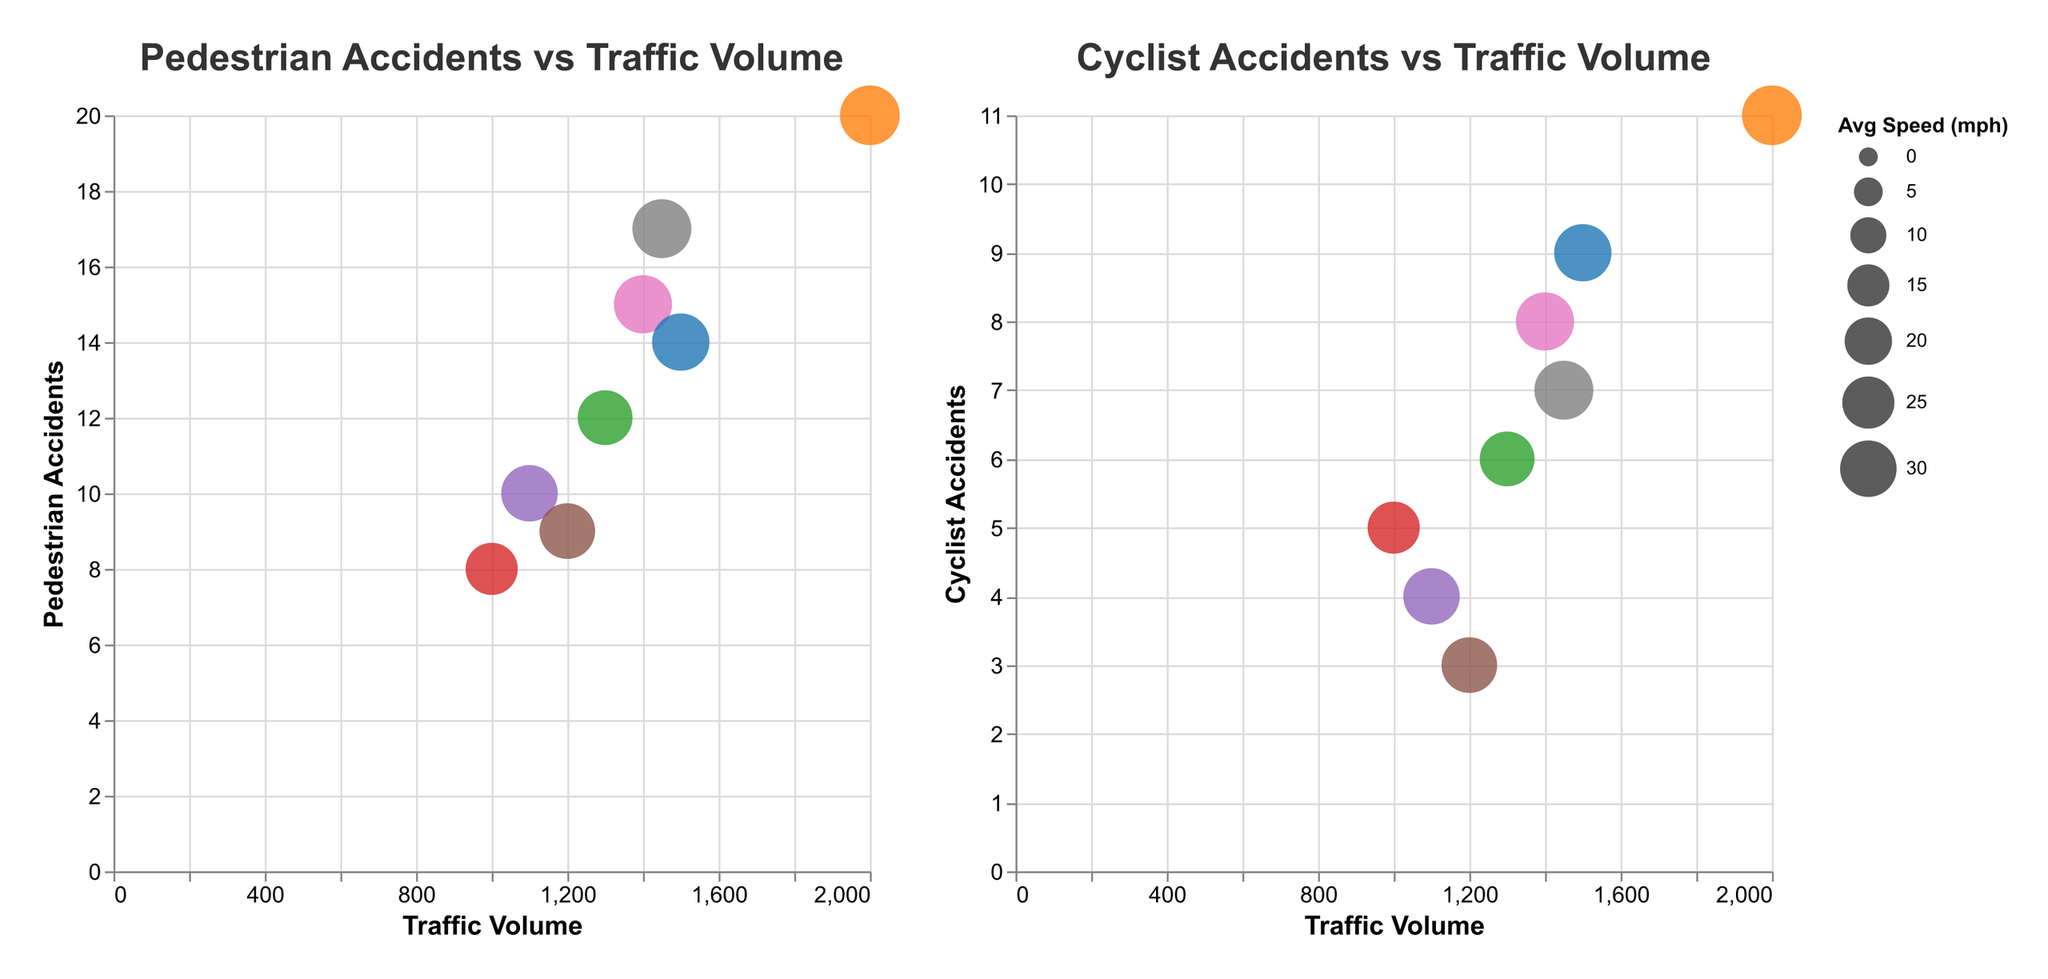How many intersections are depicted with bubbles across both plots? There are 8 data points in each subplot, with each bubble representing a different intersection.
Answer: 8 Which intersection has the highest number of pedestrian accidents and how many does it have? The intersection "Central Ave & Henry Johnson Blvd" has the highest number of pedestrian accidents with 20. This can be observed by looking at the y-axis value for "Pedestrian Accidents" in the first subplot.
Answer: Central Ave & Henry Johnson Blvd, 20 What's the average traffic volume across all intersections? Sum all the traffic volumes (1400 + 2000 + 1100 + 1300 + 1000 + 1500 + 1450 + 1200 = 10950) and divide by the number of intersections (8). The average traffic volume is 10950/8 = 1368.75.
Answer: 1368.75 Which intersection has the lowest average speed and what is the value? The intersection "Delaware Ave & Morton Ave" has the lowest average speed of 25 mph. This can be observed by looking at the size of the bubble, which is smallest for "Delaware Ave & Morton Ave" in both plots.
Answer: Delaware Ave & Morton Ave, 25 mph Compare the number of cyclist accidents at "Broadway & Livingston Ave" and "Western Ave & Ontario St". Which one has more? By looking at the second subplot for "Cyclist Accidents vs Traffic Volume", "Broadway & Livingston Ave" has 9 cyclist accidents while "Western Ave & Ontario St" has 7. Therefore, "Broadway & Livingston Ave" has more cyclist accidents.
Answer: Broadway & Livingston Ave Which intersection experiences more pedestrian accidents at the same traffic volume: "Washington Ave & Lark St" or "New Scotland Ave & South Lake Ave"? Both intersections have a similar traffic volume: "Washington Ave & Lark St" has 1400 and "New Scotland Ave & South Lake Ave" has 1200. "Washington Ave & Lark St" has 15 pedestrian accidents, while "New Scotland Ave & South Lake Ave" has 9. Therefore, "Washington Ave & Lark St" experiences more pedestrian accidents at a similar traffic volume.
Answer: Washington Ave & Lark St Which intersection has the highest average speed and what is the value? The intersection "Central Ave & Henry Johnson Blvd" has the highest average speed of 34 mph. This is denoted by the largest size of the bubble in both plots.
Answer: Central Ave & Henry Johnson Blvd, 34 mph How do the numbers of cyclist accidents compare between "Clinton Ave & N Pearl St" and "Washington Ave & Lark St"? By looking at the second subplot, "Clinton Ave & N Pearl St" has 6 cyclist accidents, and "Washington Ave & Lark St" has 8. Therefore, "Washington Ave & Lark St" has more cyclist accidents than "Clinton Ave & N Pearl St".
Answer: Washington Ave & Lark St Are pedestrian accidents generally higher or lower than cyclist accidents for the same intersections? By comparing the y-axes in both subplots, it is observed that many intersections have higher values for pedestrian accidents than cyclist accidents. For instance, "Central Ave & Henry Johnson Blvd" has 20 pedestrian accidents and 11 cyclist accidents, showing a general trend of higher pedestrian than cyclist accidents.
Answer: Higher 